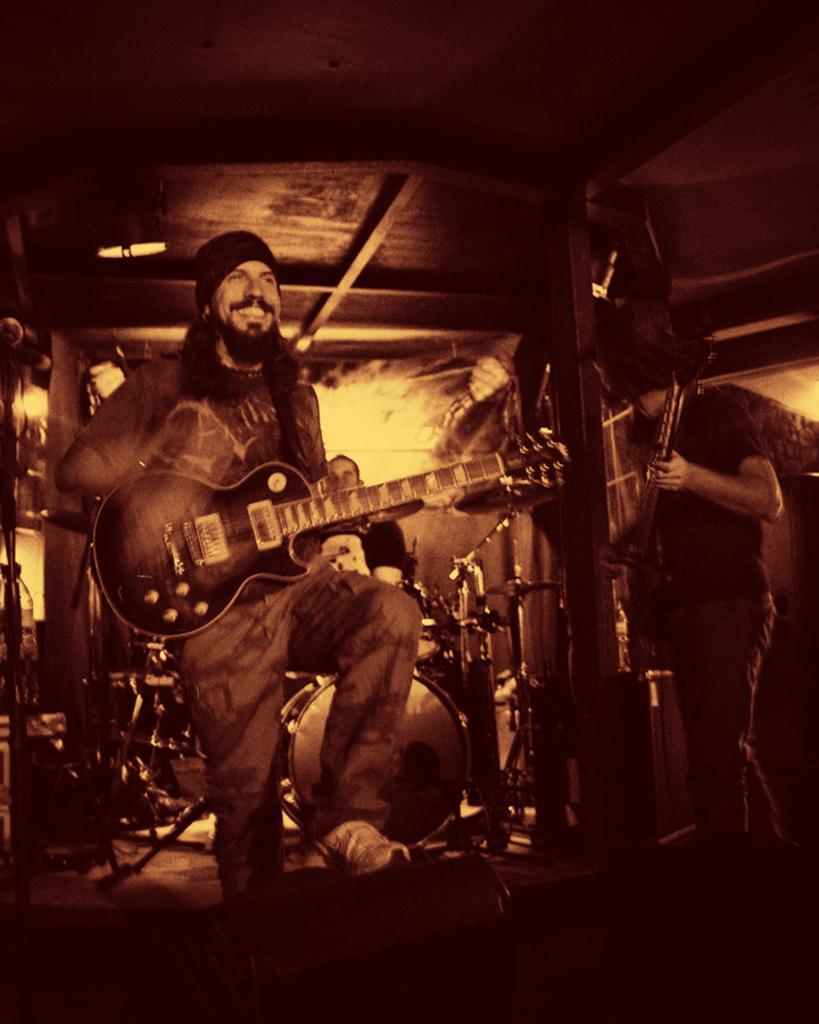Describe this image in one or two sentences. In this image i can see a person standing and holding a guitar. In the background i can see few other persons holding musical instruments, and few musical instruments. 